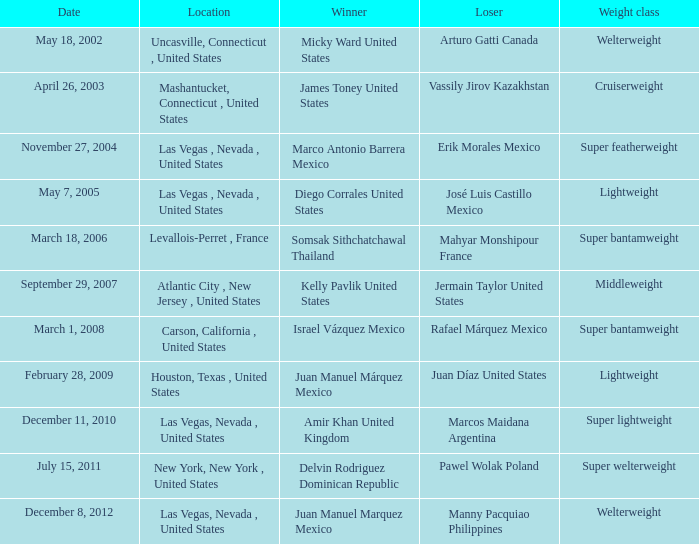Help me parse the entirety of this table. {'header': ['Date', 'Location', 'Winner', 'Loser', 'Weight class'], 'rows': [['May 18, 2002', 'Uncasville, Connecticut , United States', 'Micky Ward United States', 'Arturo Gatti Canada', 'Welterweight'], ['April 26, 2003', 'Mashantucket, Connecticut , United States', 'James Toney United States', 'Vassily Jirov Kazakhstan', 'Cruiserweight'], ['November 27, 2004', 'Las Vegas , Nevada , United States', 'Marco Antonio Barrera Mexico', 'Erik Morales Mexico', 'Super featherweight'], ['May 7, 2005', 'Las Vegas , Nevada , United States', 'Diego Corrales United States', 'José Luis Castillo Mexico', 'Lightweight'], ['March 18, 2006', 'Levallois-Perret , France', 'Somsak Sithchatchawal Thailand', 'Mahyar Monshipour France', 'Super bantamweight'], ['September 29, 2007', 'Atlantic City , New Jersey , United States', 'Kelly Pavlik United States', 'Jermain Taylor United States', 'Middleweight'], ['March 1, 2008', 'Carson, California , United States', 'Israel Vázquez Mexico', 'Rafael Márquez Mexico', 'Super bantamweight'], ['February 28, 2009', 'Houston, Texas , United States', 'Juan Manuel Márquez Mexico', 'Juan Díaz United States', 'Lightweight'], ['December 11, 2010', 'Las Vegas, Nevada , United States', 'Amir Khan United Kingdom', 'Marcos Maidana Argentina', 'Super lightweight'], ['July 15, 2011', 'New York, New York , United States', 'Delvin Rodriguez Dominican Republic', 'Pawel Wolak Poland', 'Super welterweight'], ['December 8, 2012', 'Las Vegas, Nevada , United States', 'Juan Manuel Marquez Mexico', 'Manny Pacquiao Philippines', 'Welterweight']]} How many years were lightweight class on february 28, 2009? 1.0. 